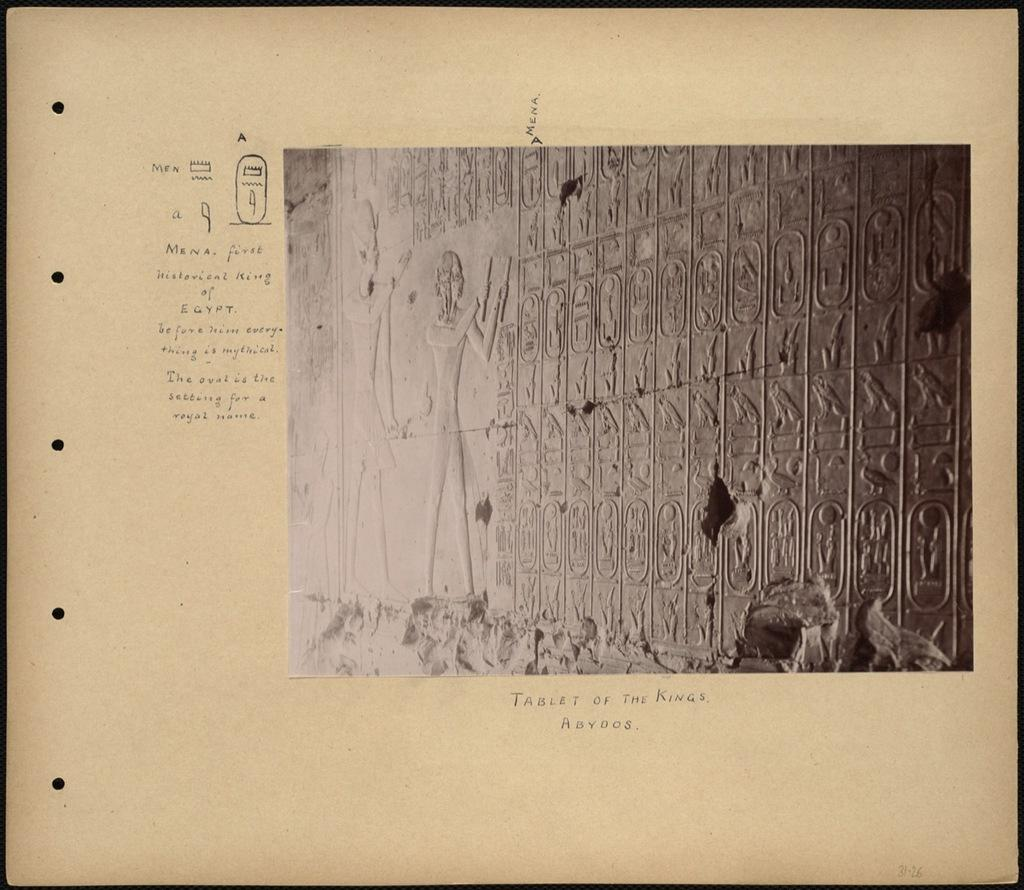What is present on the wall in the image? There is a board on the wall. What is written or displayed on the board? There is text on the board. Is there a carriage carrying passengers in the image? No, there is no carriage present in the image. What type of verse or poetry is written on the board? There is no verse or poetry on the board; it only contains text. 